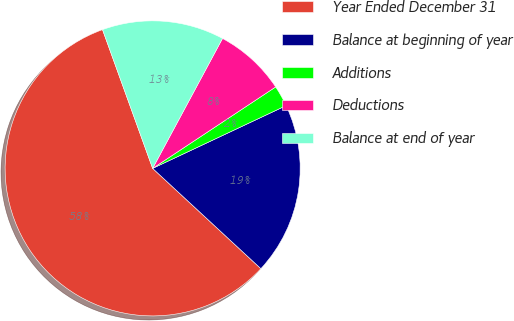Convert chart to OTSL. <chart><loc_0><loc_0><loc_500><loc_500><pie_chart><fcel>Year Ended December 31<fcel>Balance at beginning of year<fcel>Additions<fcel>Deductions<fcel>Balance at end of year<nl><fcel>57.59%<fcel>18.89%<fcel>2.31%<fcel>7.84%<fcel>13.37%<nl></chart> 